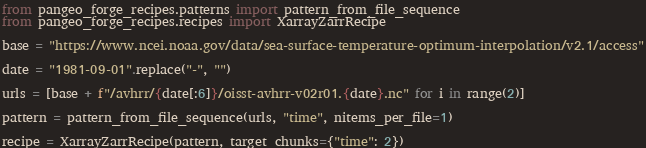<code> <loc_0><loc_0><loc_500><loc_500><_Python_>from pangeo_forge_recipes.patterns import pattern_from_file_sequence
from pangeo_forge_recipes.recipes import XarrayZarrRecipe

base = "https://www.ncei.noaa.gov/data/sea-surface-temperature-optimum-interpolation/v2.1/access"

date = "1981-09-01".replace("-", "")

urls = [base + f"/avhrr/{date[:6]}/oisst-avhrr-v02r01.{date}.nc" for i in range(2)]

pattern = pattern_from_file_sequence(urls, "time", nitems_per_file=1)

recipe = XarrayZarrRecipe(pattern, target_chunks={"time": 2})
</code> 